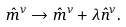Convert formula to latex. <formula><loc_0><loc_0><loc_500><loc_500>\hat { m } ^ { \nu } \rightarrow \hat { m } ^ { \nu } + \lambda \hat { n } ^ { \nu } .</formula> 